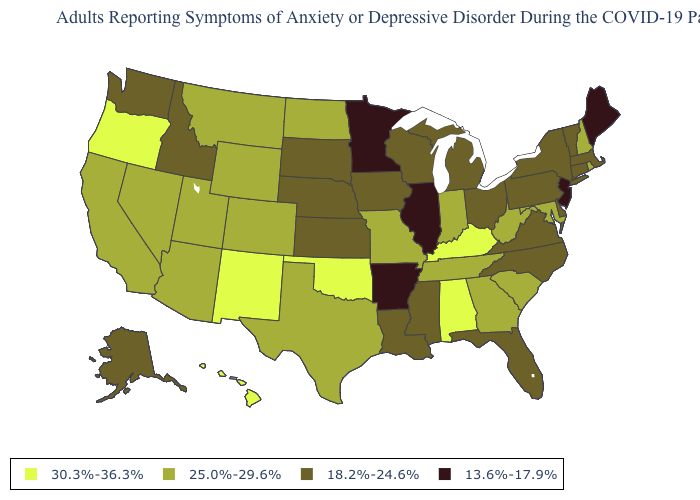Name the states that have a value in the range 30.3%-36.3%?
Be succinct. Alabama, Hawaii, Kentucky, New Mexico, Oklahoma, Oregon. What is the value of Idaho?
Concise answer only. 18.2%-24.6%. What is the value of Oregon?
Be succinct. 30.3%-36.3%. How many symbols are there in the legend?
Write a very short answer. 4. Does Oregon have the highest value in the West?
Be succinct. Yes. What is the value of Illinois?
Write a very short answer. 13.6%-17.9%. Does New Jersey have a lower value than Illinois?
Be succinct. No. How many symbols are there in the legend?
Short answer required. 4. Name the states that have a value in the range 13.6%-17.9%?
Answer briefly. Arkansas, Illinois, Maine, Minnesota, New Jersey. Does North Dakota have the lowest value in the USA?
Keep it brief. No. Does Oklahoma have the highest value in the USA?
Quick response, please. Yes. What is the value of Nebraska?
Short answer required. 18.2%-24.6%. Name the states that have a value in the range 25.0%-29.6%?
Write a very short answer. Arizona, California, Colorado, Georgia, Indiana, Maryland, Missouri, Montana, Nevada, New Hampshire, North Dakota, Rhode Island, South Carolina, Tennessee, Texas, Utah, West Virginia, Wyoming. 